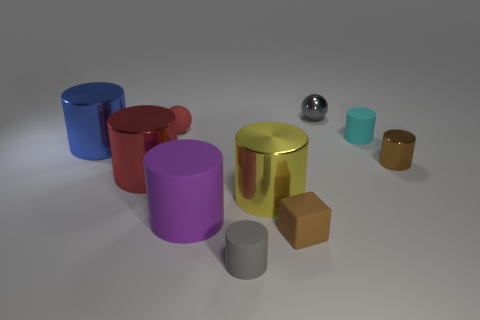Subtract all blue cylinders. How many cylinders are left? 6 Subtract all tiny brown cylinders. How many cylinders are left? 6 Subtract all gray cylinders. Subtract all blue spheres. How many cylinders are left? 6 Subtract all balls. How many objects are left? 8 Subtract all small cyan cylinders. Subtract all brown things. How many objects are left? 7 Add 6 large objects. How many large objects are left? 10 Add 9 cyan shiny things. How many cyan shiny things exist? 9 Subtract 1 yellow cylinders. How many objects are left? 9 